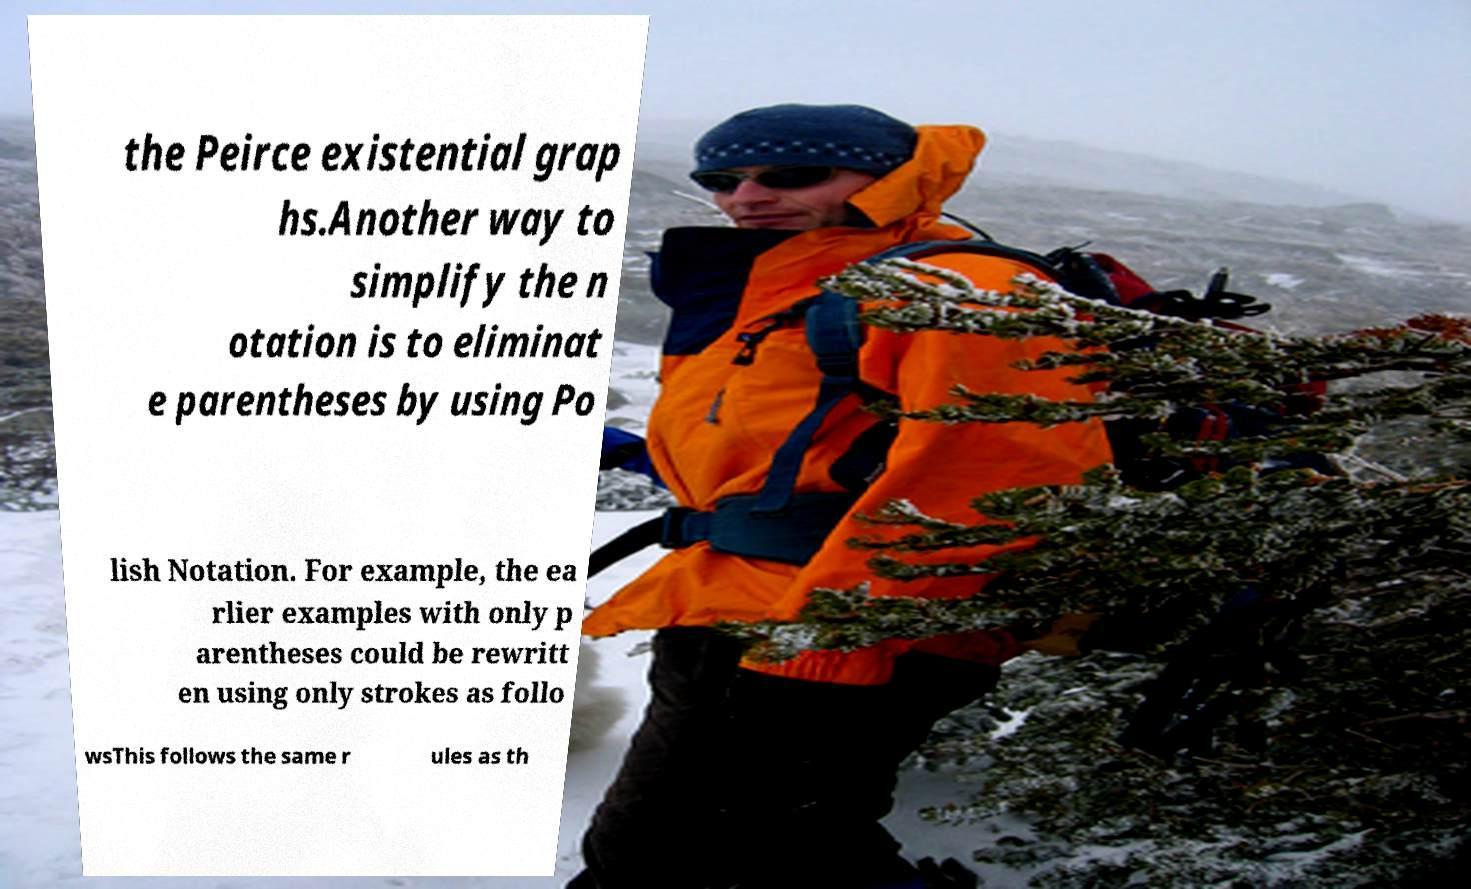Please identify and transcribe the text found in this image. the Peirce existential grap hs.Another way to simplify the n otation is to eliminat e parentheses by using Po lish Notation. For example, the ea rlier examples with only p arentheses could be rewritt en using only strokes as follo wsThis follows the same r ules as th 